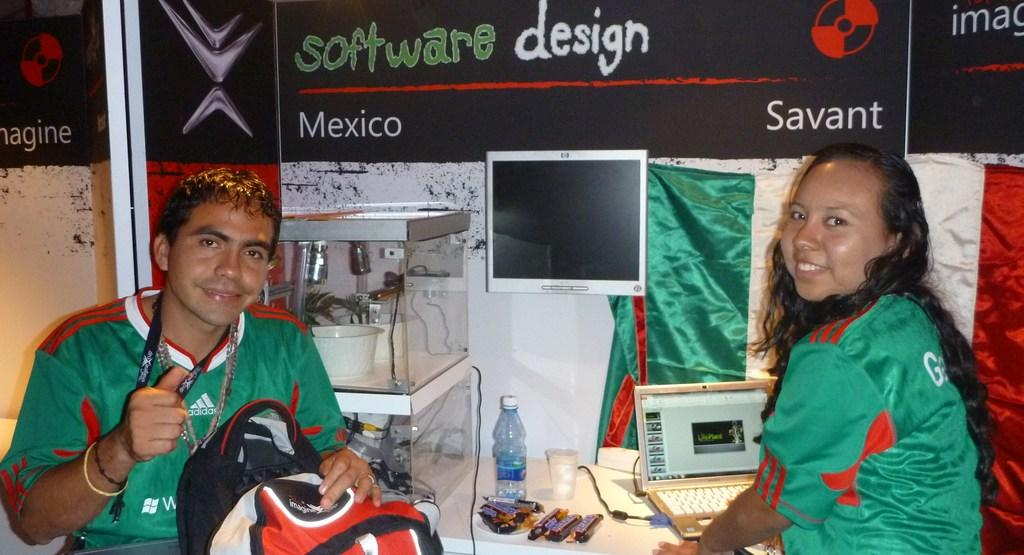<image>
Give a short and clear explanation of the subsequent image. Two people are sitting at a desk and there is a sign above them that says software design in green and white letters. 